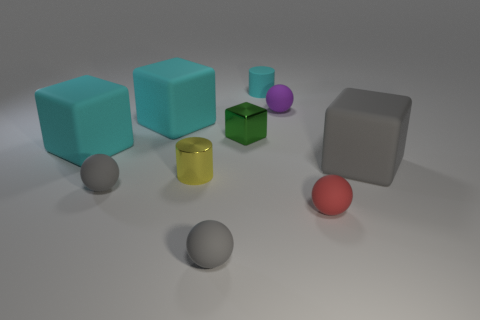There is a large rubber object that is behind the green shiny thing; is it the same color as the rubber cylinder?
Keep it short and to the point. Yes. What is the size of the gray rubber block?
Keep it short and to the point. Large. The gray rubber object that is behind the small red object and left of the gray matte cube has what shape?
Provide a succinct answer. Sphere. The other metal object that is the same shape as the large gray thing is what color?
Ensure brevity in your answer.  Green. How many things are cyan rubber blocks that are behind the green metal block or tiny cylinders that are in front of the small purple matte sphere?
Ensure brevity in your answer.  2. The red thing has what shape?
Your answer should be very brief. Sphere. How many tiny green cubes are made of the same material as the yellow cylinder?
Keep it short and to the point. 1. The metal cylinder has what color?
Your answer should be very brief. Yellow. What color is the metallic cube that is the same size as the red matte object?
Provide a succinct answer. Green. Are there any matte blocks that have the same color as the rubber cylinder?
Your answer should be very brief. Yes. 